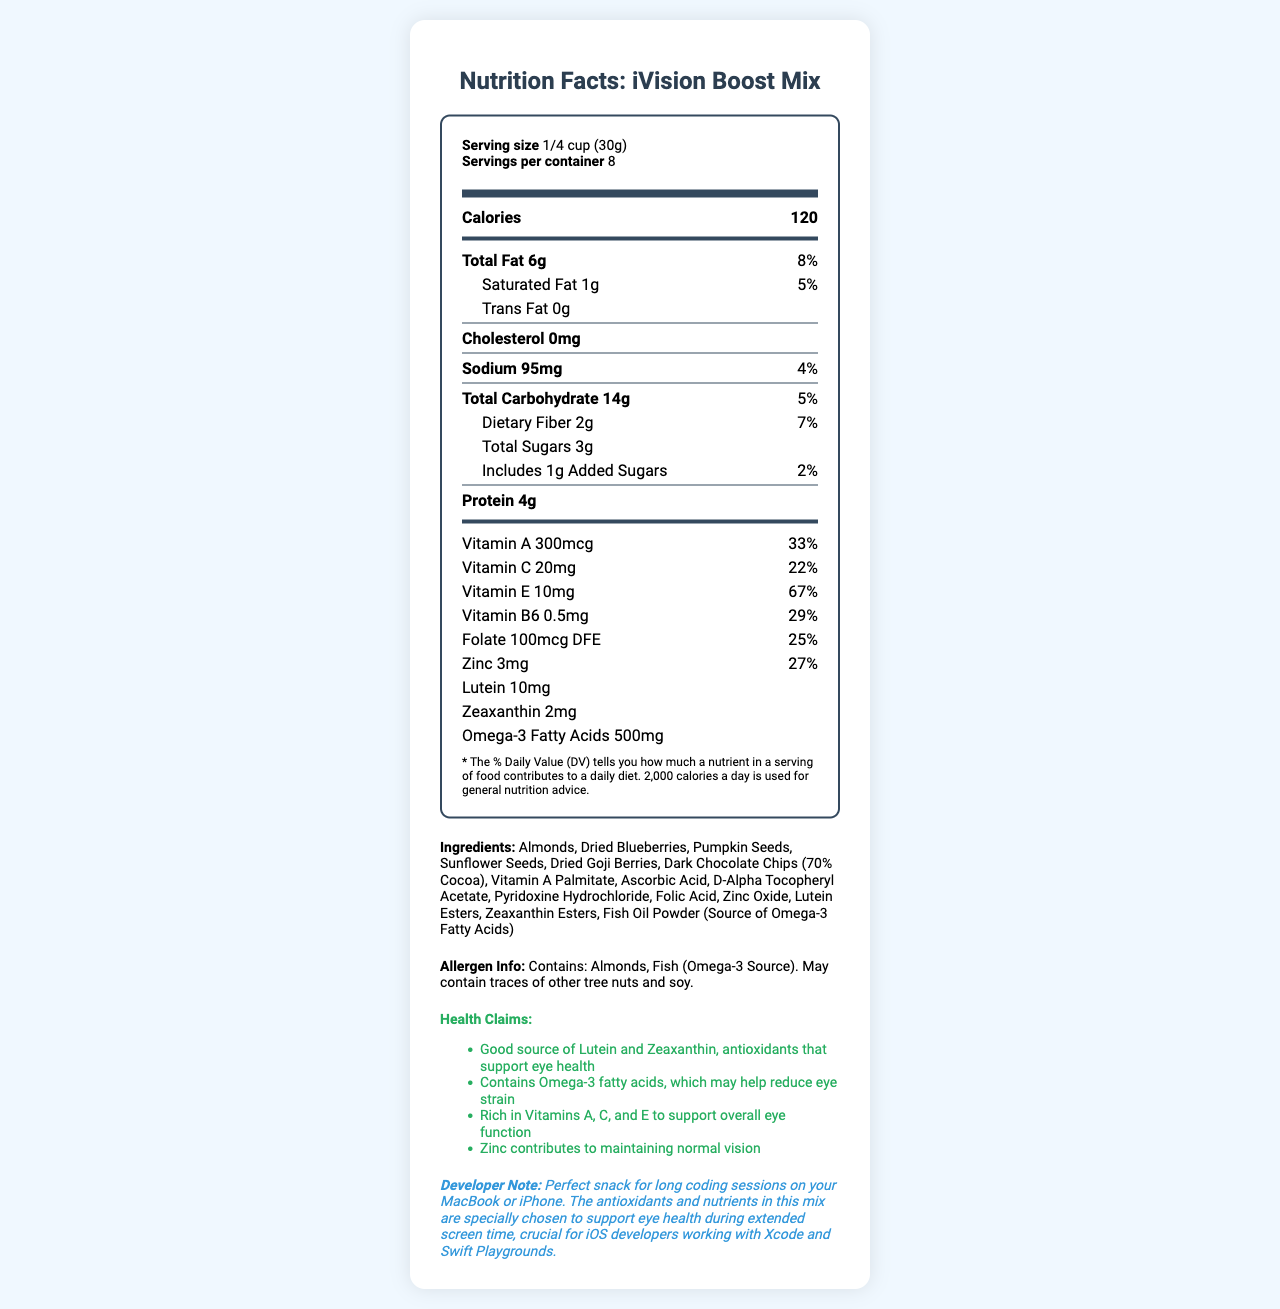what is the serving size? The document specifies the serving size as "1/4 cup (30g)" under the serving information section.
Answer: 1/4 cup (30g) how many calories are in one serving? The calorie count is listed as 120 in the nutrient breakdown section.
Answer: 120 how many servings are in each container? The document states "Servings per container: 8" in the serving information section.
Answer: 8 what is the amount of Sodium per serving? The amount of Sodium per serving is specified as 95mg in the nutrient breakdown section.
Answer: 95mg how much Vitamin A does this product contain per serving? The document lists the Vitamin A content as 300mcg in the nutrient breakdown section.
Answer: 300mcg what is the percentage of daily value for Vitamin C per serving? According to the document, the percentage of daily value for Vitamin C per serving is 22%.
Answer: 22% what ingredients are included in the iVision Boost Mix? The document lists the ingredients in the ingredients section.
Answer: Almonds, Dried Blueberries, Pumpkin Seeds, Sunflower Seeds, Dried Goji Berries, Dark Chocolate Chips (70% Cocoa), Vitamin A Palmitate, Ascorbic Acid, D-Alpha Tocopheryl Acetate, Pyridoxine Hydrochloride, Folic Acid, Zinc Oxide, Lutein Esters, Zeaxanthin Esters, Fish Oil Powder (Source of Omega-3 Fatty Acids) which of the following is not an ingredient in iVision Boost Mix? A. Dried Blueberries B. Chocolate Chips C. Artificial Preservatives D. Pumpkin Seeds The ingredients listed do not include artificial preservatives.
Answer: C. Artificial Preservatives how does the iVision Boost Mix support eye health? A. Contains antioxidants B. Contains Omega-3 fatty acids C. Contains Vitamins A, C, and E D. All of the above The health claims section mentions antioxidants, Omega-3 fatty acids, and Vitamins A, C, and E to support eye health.
Answer: D. All of the above does this snack mix contain cholesterol? The document states "Cholesterol 0mg," indicating that there is no cholesterol.
Answer: No what should you do after opening the package to maintain freshness? The storage instructions mention resealing the package to maintain freshness after opening.
Answer: Reseal package after opening to maintain freshness. can you tell the brand of this snack mix? The brand is not specified in the visual information provided in the document.
Answer: Not enough information summarize the main idea of the document. The document provides comprehensive information about the nutritional benefits and ingredients of iVision Boost Mix, emphasizing its utility for eye health amid extended screen time.
Answer: The document details the nutritional information of the iVision Boost Mix, a vitamin-fortified snack mix designed to support eye health during prolonged screen time. It includes serving size, servings per container, nutrient breakdown, ingredients, allergen info, health claims, and storage instructions, specifically highlighting nutrients beneficial for developers who spend long hours in front of screens. 